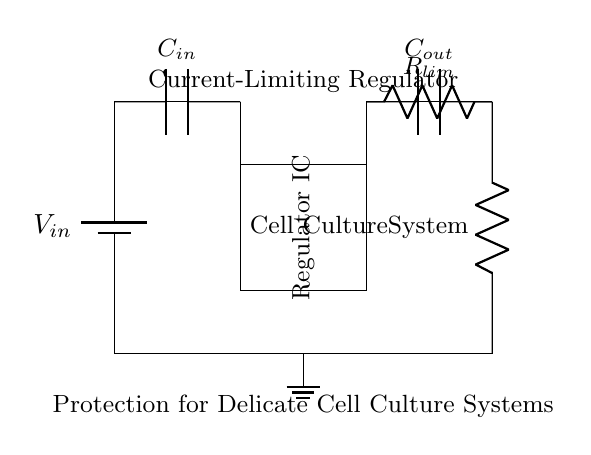What type of component is the Regulator IC? The Regulator IC is a type of integrated circuit that manages the output voltage and current, ensuring they remain within specified limits for safe operation of the load.
Answer: Integrated circuit What is the function of the resistor labeled Rlim? The resistor labeled Rlim serves to limit the current flowing to the load, protecting sensitive components such as cell cultures from excessive current that could cause damage.
Answer: Current limiter What are the two capacitors present in the circuit? The two capacitors present in the circuit are C_in and C_out, which are responsible for filtering and stabilizing the input and output voltages, respectively.
Answer: C_in and C_out What is the load connected to the regulator? The load connected to the regulator is the cell culture system, which requires careful control of current and voltage for proper operation.
Answer: Cell culture system How does the current-limiting feature protect the cell culture system? The current-limiting feature protects the cell culture system by ensuring that if the current exceeds a predetermined threshold, it restricts the current flow, thereby preventing potential damage to the cells from overcurrent conditions.
Answer: By restricting excessive current What happens if the input voltage exceeds the safe limit? If the input voltage exceeds the safe limit, the regulator's protection mechanisms should ideally prevent output from exceeding safe levels, but inadequate design could lead to damage to the cell culture system.
Answer: Potential damage 